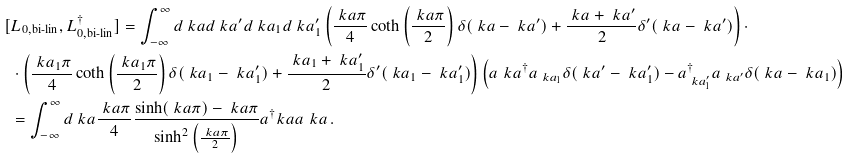<formula> <loc_0><loc_0><loc_500><loc_500>[ & \L L _ { 0 , \text {bi-lin} } , \L L _ { 0 , \text {bi-lin} } ^ { \dagger } ] = \int _ { - \infty } ^ { \infty } d \ k a d \ k a ^ { \prime } d \ k a _ { 1 } d \ k a _ { 1 } ^ { \prime } \left ( \frac { \ k a \pi } { 4 } \coth \left ( \frac { \ k a \pi } { 2 } \right ) \delta ( \ k a - \ k a ^ { \prime } ) + \frac { \ k a + \ k a ^ { \prime } } { 2 } \delta ^ { \prime } ( \ k a - \ k a ^ { \prime } ) \right ) \cdot \\ & \cdot \left ( \frac { \ k a _ { 1 } \pi } { 4 } \coth \left ( \frac { \ k a _ { 1 } \pi } { 2 } \right ) \delta ( \ k a _ { 1 } - \ k a _ { 1 } ^ { \prime } ) + \frac { \ k a _ { 1 } + \ k a _ { 1 } ^ { \prime } } { 2 } \delta ^ { \prime } ( \ k a _ { 1 } - \ k a _ { 1 } ^ { \prime } ) \right ) \left ( a _ { \ } k a ^ { \dagger } a _ { \ k a _ { 1 } } \delta ( \ k a ^ { \prime } - \ k a _ { 1 } ^ { \prime } ) - a _ { \ k a _ { 1 } ^ { \prime } } ^ { \dagger } a _ { \ k a ^ { \prime } } \delta ( \ k a - \ k a _ { 1 } ) \right ) \\ & = \int _ { - \infty } ^ { \infty } d \ k a \frac { \ k a \pi } { 4 } \frac { \sinh ( \ k a \pi ) - \ k a \pi } { \sinh ^ { 2 } \left ( \frac { \ k a \pi } { 2 } \right ) } a ^ { \dagger } _ { \ } k a a _ { \ } k a \, .</formula> 